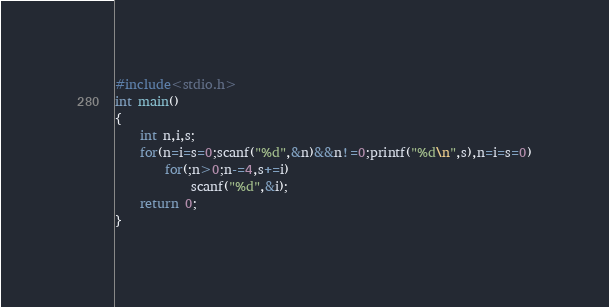Convert code to text. <code><loc_0><loc_0><loc_500><loc_500><_C_>#include<stdio.h>
int main()
{
	int n,i,s;
	for(n=i=s=0;scanf("%d",&n)&&n!=0;printf("%d\n",s),n=i=s=0)
		for(;n>0;n-=4,s+=i)
			scanf("%d",&i);
	return 0;
}</code> 